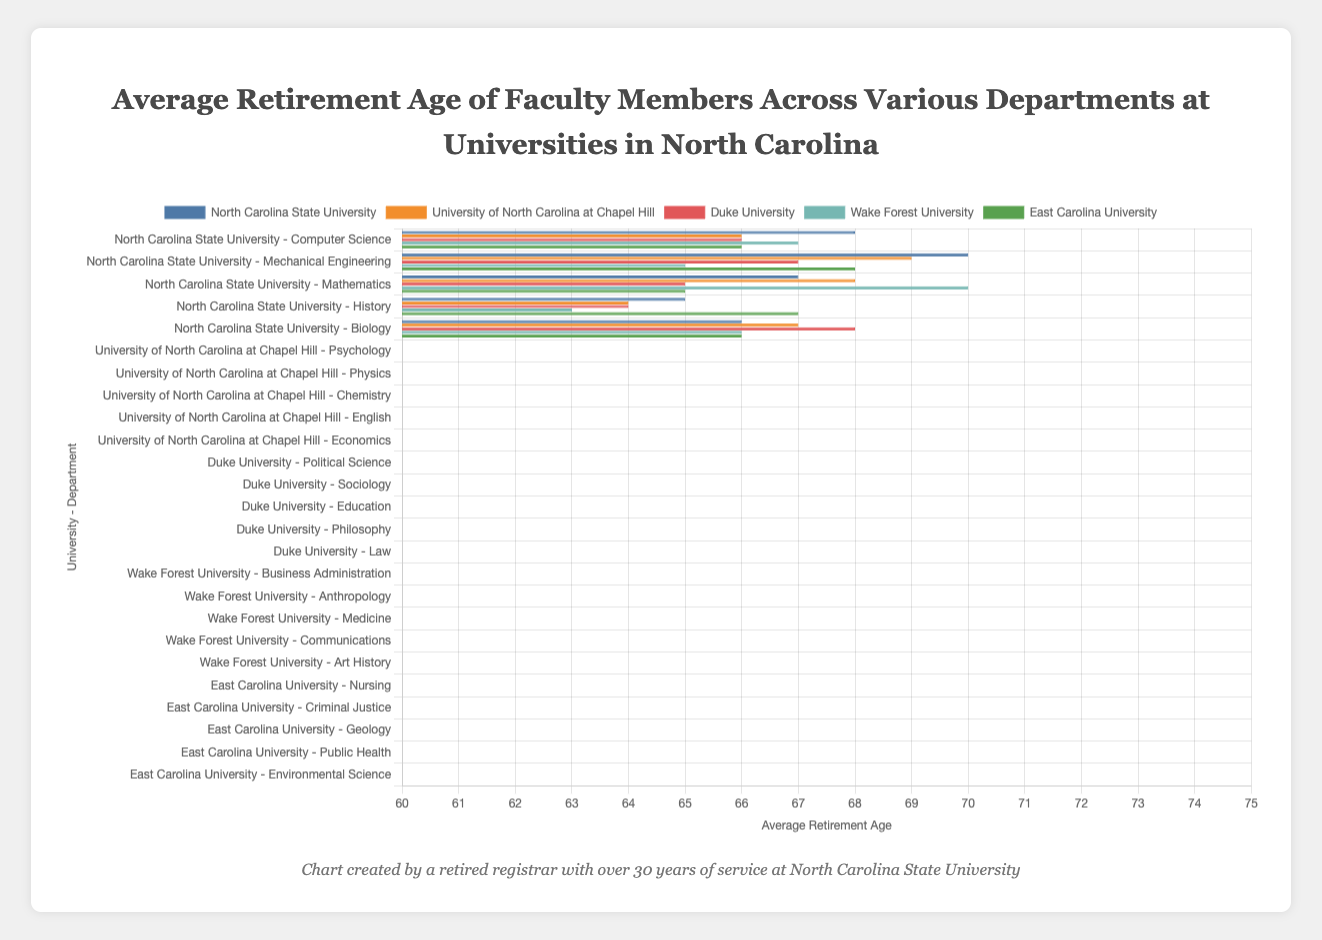What is the average retirement age for faculty members in the Medicine department at Wake Forest University? The bar representing the Medicine department at Wake Forest University indicates an average retirement age of 70.
Answer: 70 Which department at Duke University has the youngest average retirement age? By comparing the heights of the bars for Duke University, the Philosophy department has the lowest average retirement age, which is 64.
Answer: Philosophy (64) How much older, on average, do faculty members retire in the Mechanical Engineering department at North Carolina State University compared to the English department at the University of North Carolina at Chapel Hill? The Mechanical Engineering department at North Carolina State University has an average retirement age of 70, and the English department at UNC Chapel Hill has an average retirement age of 64. The difference is 70 - 64 = 6 years.
Answer: 6 years What is the average retirement age for departments at East Carolina University? The average retirement ages for East Carolina University departments are: Nursing (66), Criminal Justice (68), Geology (65), Public Health (67), Environmental Science (66). The arithmetic mean is (66 + 68 + 65 + 67 + 66) / 5 = 66.4.
Answer: 66.4 What is the range (difference between the maximum and minimum retirement ages) for departments at North Carolina State University? The retirement ages are: Computer Science (68), Mechanical Engineering (70), Mathematics (67), History (65), Biology (66). The range is 70 - 65 = 5 years.
Answer: 5 years How does the average retirement age in the Biology department at North Carolina State University compare to the Environmental Science department at East Carolina University? Both departments have an average retirement age of 66.
Answer: Equal (66) Which department has the lowest average retirement age at Wake Forest University? At Wake Forest University, the Communications department has the lowest average retirement age of 63.
Answer: Communications (63) 